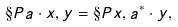Convert formula to latex. <formula><loc_0><loc_0><loc_500><loc_500>\S P { a \cdot x , y } = \S P { x , a ^ { * } \cdot y } ,</formula> 